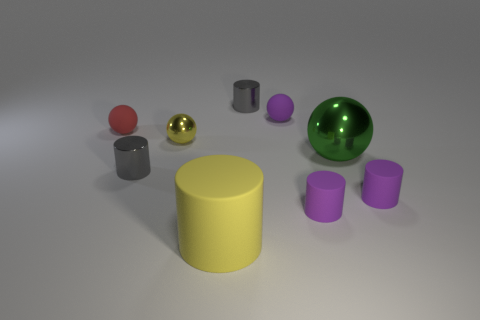Does the gray metallic thing that is in front of the red rubber object have the same size as the yellow cylinder?
Your answer should be very brief. No. The gray cylinder on the left side of the cylinder that is behind the matte ball that is behind the small red object is made of what material?
Your answer should be compact. Metal. There is a shiny cylinder that is in front of the red matte object; does it have the same color as the big object that is right of the yellow rubber cylinder?
Make the answer very short. No. What material is the tiny yellow sphere that is behind the purple cylinder that is to the left of the green object?
Your response must be concise. Metal. The thing that is the same size as the green metal sphere is what color?
Give a very brief answer. Yellow. Is the shape of the big yellow thing the same as the gray metallic thing that is in front of the tiny red matte ball?
Offer a terse response. Yes. There is a small object that is the same color as the big matte cylinder; what shape is it?
Provide a succinct answer. Sphere. There is a large object that is right of the yellow thing that is in front of the tiny yellow object; what number of small matte objects are on the right side of it?
Offer a very short reply. 1. What size is the rubber ball that is on the left side of the shiny object that is in front of the green sphere?
Your answer should be very brief. Small. There is a yellow cylinder that is made of the same material as the small red thing; what is its size?
Provide a succinct answer. Large. 